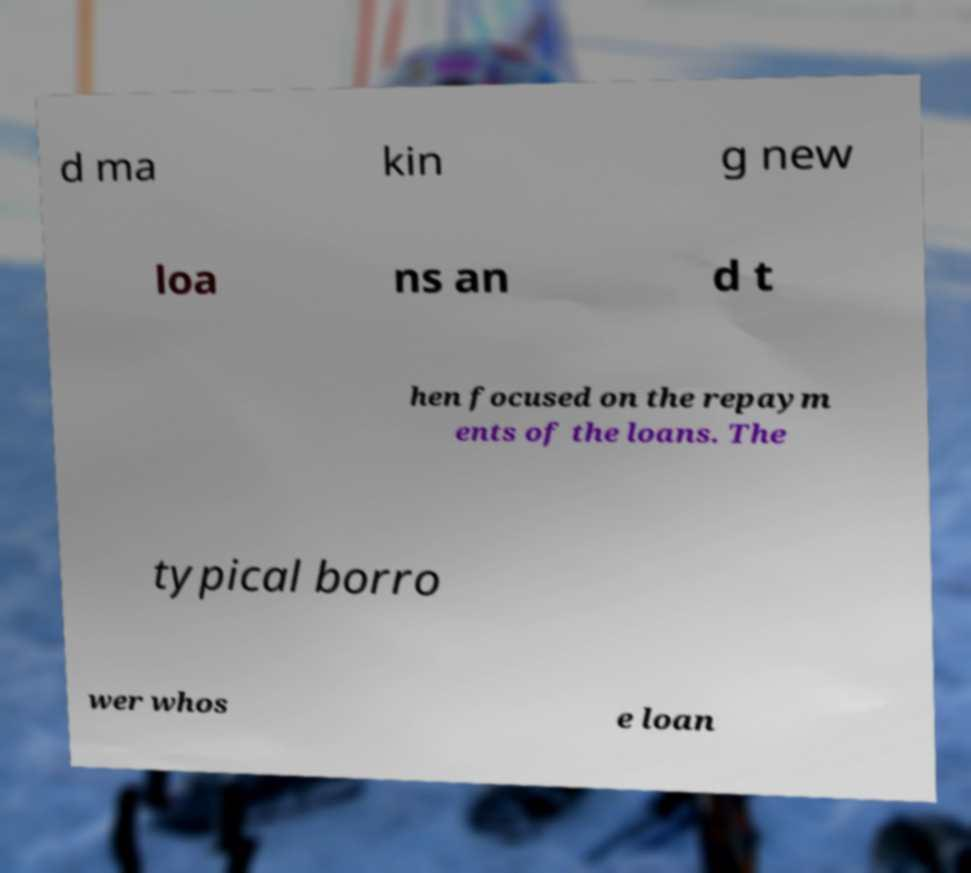There's text embedded in this image that I need extracted. Can you transcribe it verbatim? d ma kin g new loa ns an d t hen focused on the repaym ents of the loans. The typical borro wer whos e loan 